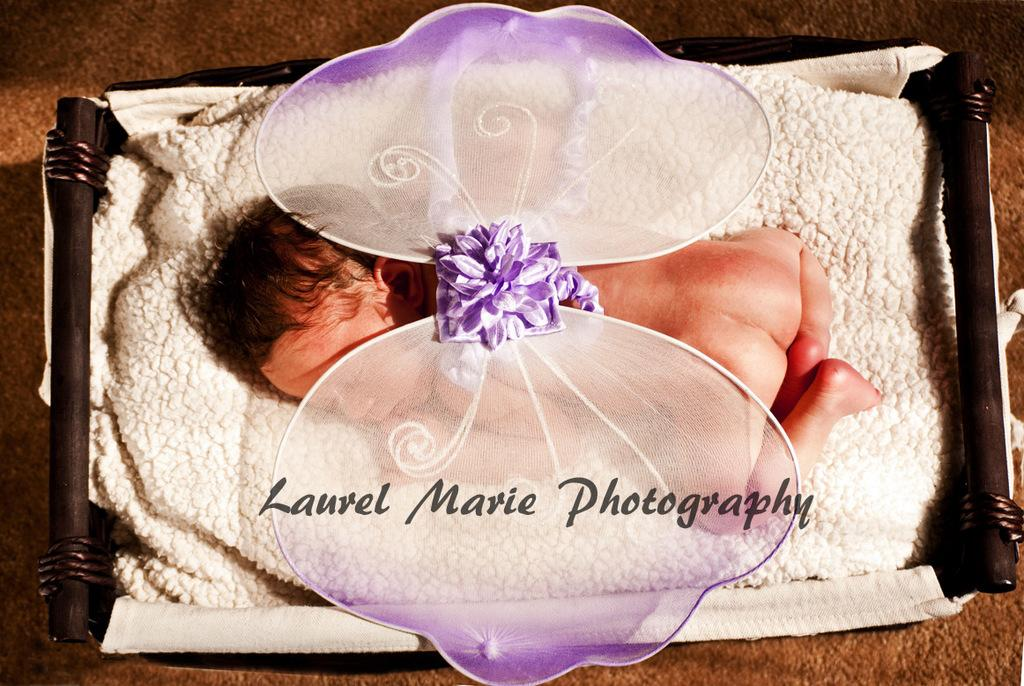What is the main subject of the image? There is a baby in the image. What is the baby doing in the image? The baby is sleeping. Where is the baby located in the image? The baby is in a cradle. What type of watch is the baby wearing in the image? There is no watch present in the image; the baby is not wearing any accessories. 